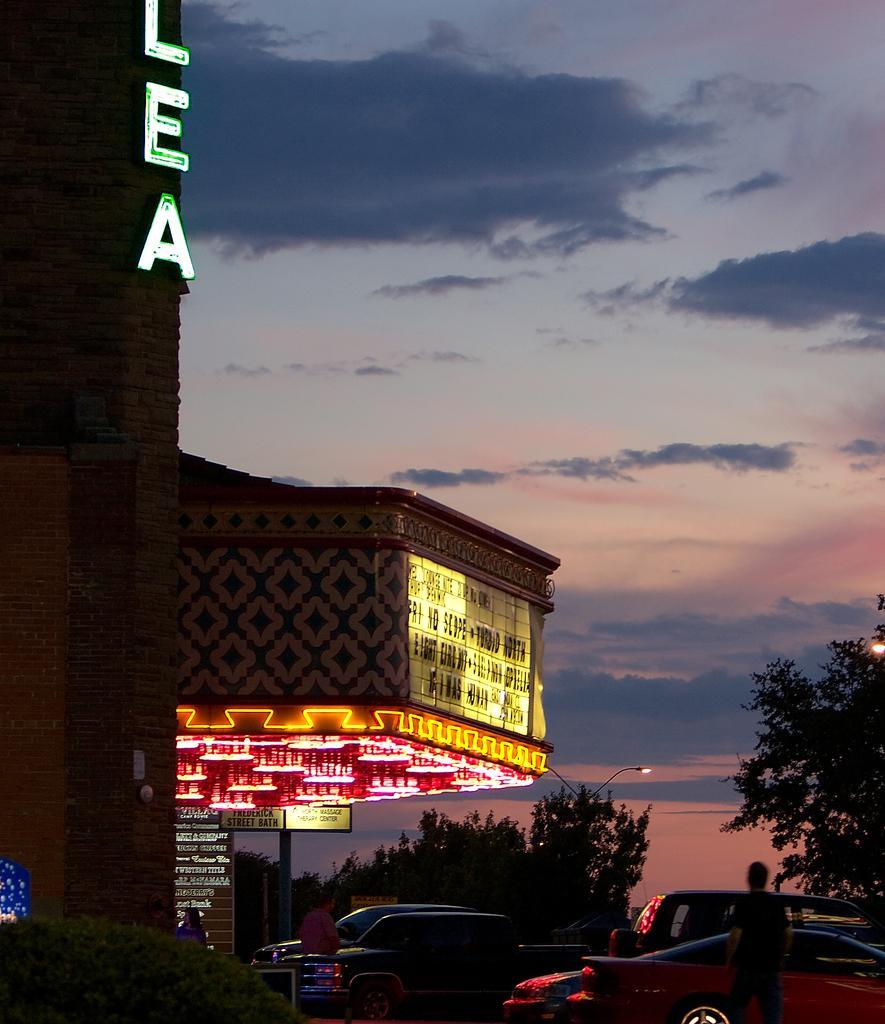Could you give a brief overview of what you see in this image? On the left side, there is a tower on which there are letters arranged. On the right side, there are vehicles on the road and there is a person standing on the road. In the background, there is a building which is having hoardings, there are trees, there is water, there are mountains and there are clouds in the sky. 